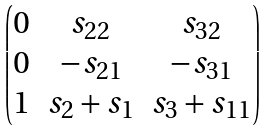<formula> <loc_0><loc_0><loc_500><loc_500>\begin{pmatrix} 0 & s _ { 2 2 } & s _ { 3 2 } \\ 0 & - s _ { 2 1 } & - s _ { 3 1 } \\ 1 & s _ { 2 } + s _ { 1 } & s _ { 3 } + s _ { 1 1 } \end{pmatrix}</formula> 